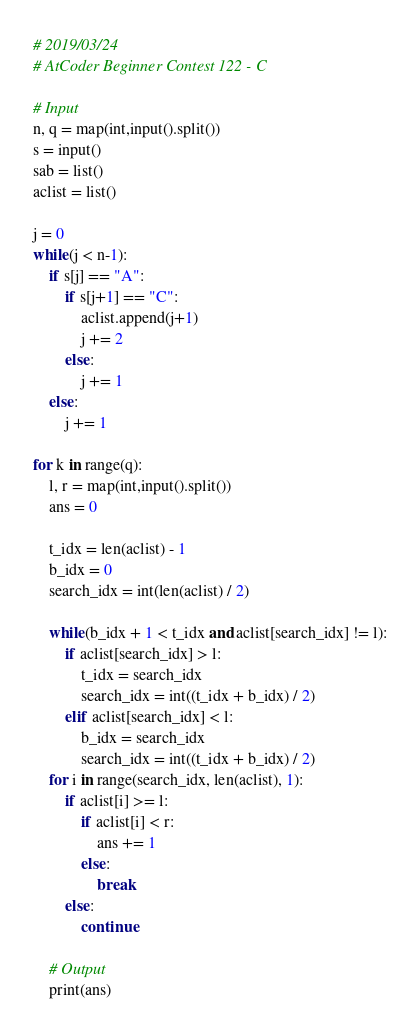<code> <loc_0><loc_0><loc_500><loc_500><_Python_># 2019/03/24
# AtCoder Beginner Contest 122 - C
 
# Input
n, q = map(int,input().split())
s = input()
sab = list()
aclist = list()
 
j = 0
while(j < n-1):
    if s[j] == "A":
        if s[j+1] == "C":
            aclist.append(j+1)
            j += 2
        else:
            j += 1
    else:
        j += 1

for k in range(q):
    l, r = map(int,input().split())
    ans = 0
    
    t_idx = len(aclist) - 1
    b_idx = 0
    search_idx = int(len(aclist) / 2)
 
    while(b_idx + 1 < t_idx and aclist[search_idx] != l):
        if aclist[search_idx] > l:
            t_idx = search_idx
            search_idx = int((t_idx + b_idx) / 2)
        elif aclist[search_idx] < l:
            b_idx = search_idx
            search_idx = int((t_idx + b_idx) / 2)
    for i in range(search_idx, len(aclist), 1):
        if aclist[i] >= l:
            if aclist[i] < r:
                ans += 1
            else:
                break
        else:
            continue
 
    # Output
    print(ans)</code> 